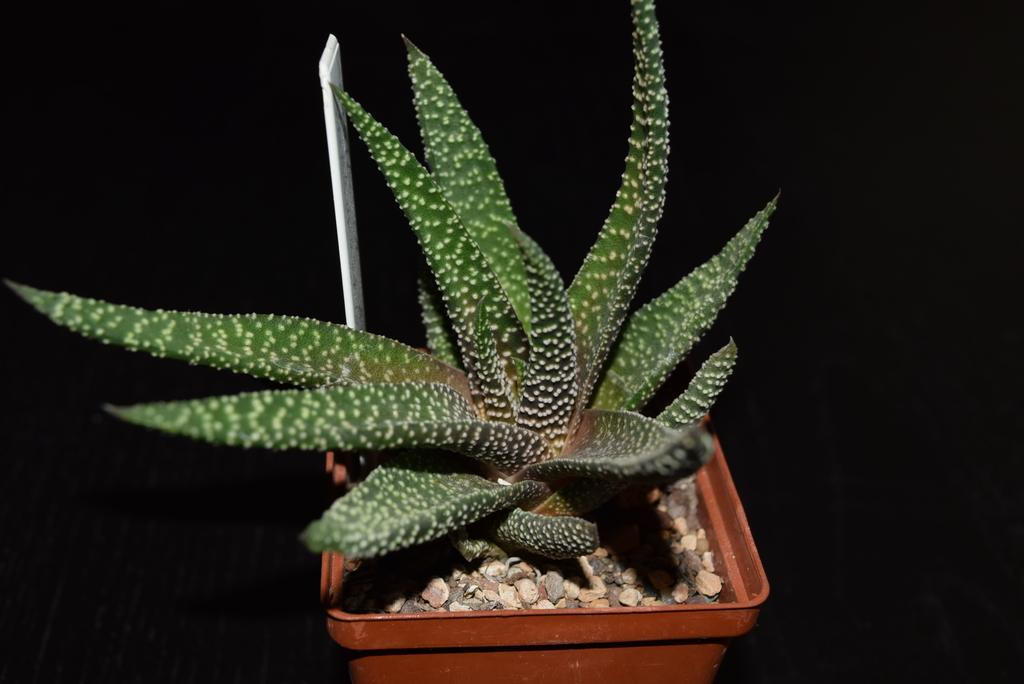What type of living organism can be seen in the image? There is a plant in the image. Can you describe the grey object in the image? There is a grey object in the image. What can be found in the flower pot in the image? There are stones in a flower pot in the image. What type of quiet can be heard coming from the church in the image? There is no church or sound present in the image, so it's not possible to determine what, if any, quiet might be heard. 